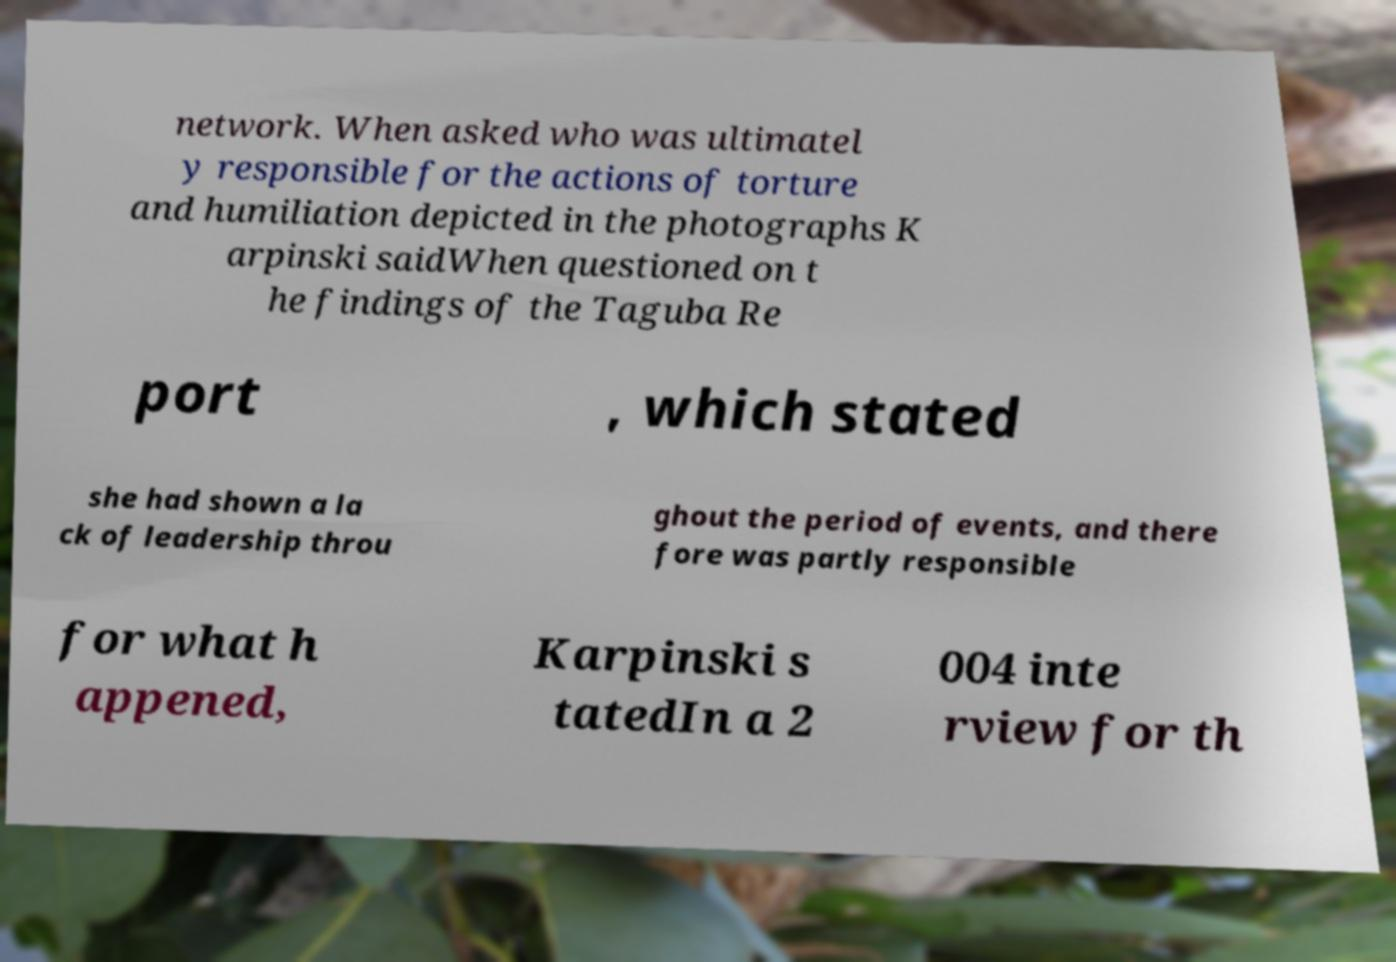What messages or text are displayed in this image? I need them in a readable, typed format. network. When asked who was ultimatel y responsible for the actions of torture and humiliation depicted in the photographs K arpinski saidWhen questioned on t he findings of the Taguba Re port , which stated she had shown a la ck of leadership throu ghout the period of events, and there fore was partly responsible for what h appened, Karpinski s tatedIn a 2 004 inte rview for th 